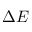<formula> <loc_0><loc_0><loc_500><loc_500>\Delta E</formula> 